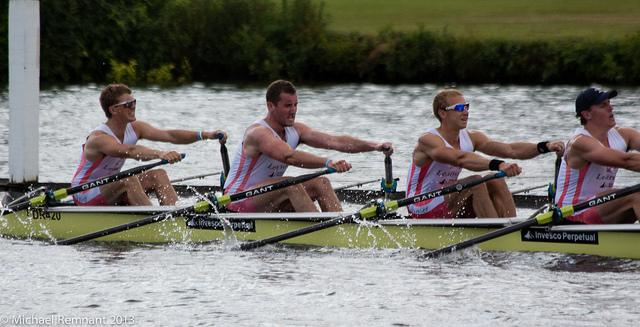Who are these people to each other? Please explain your reasoning. teammates. The people are teammates. 